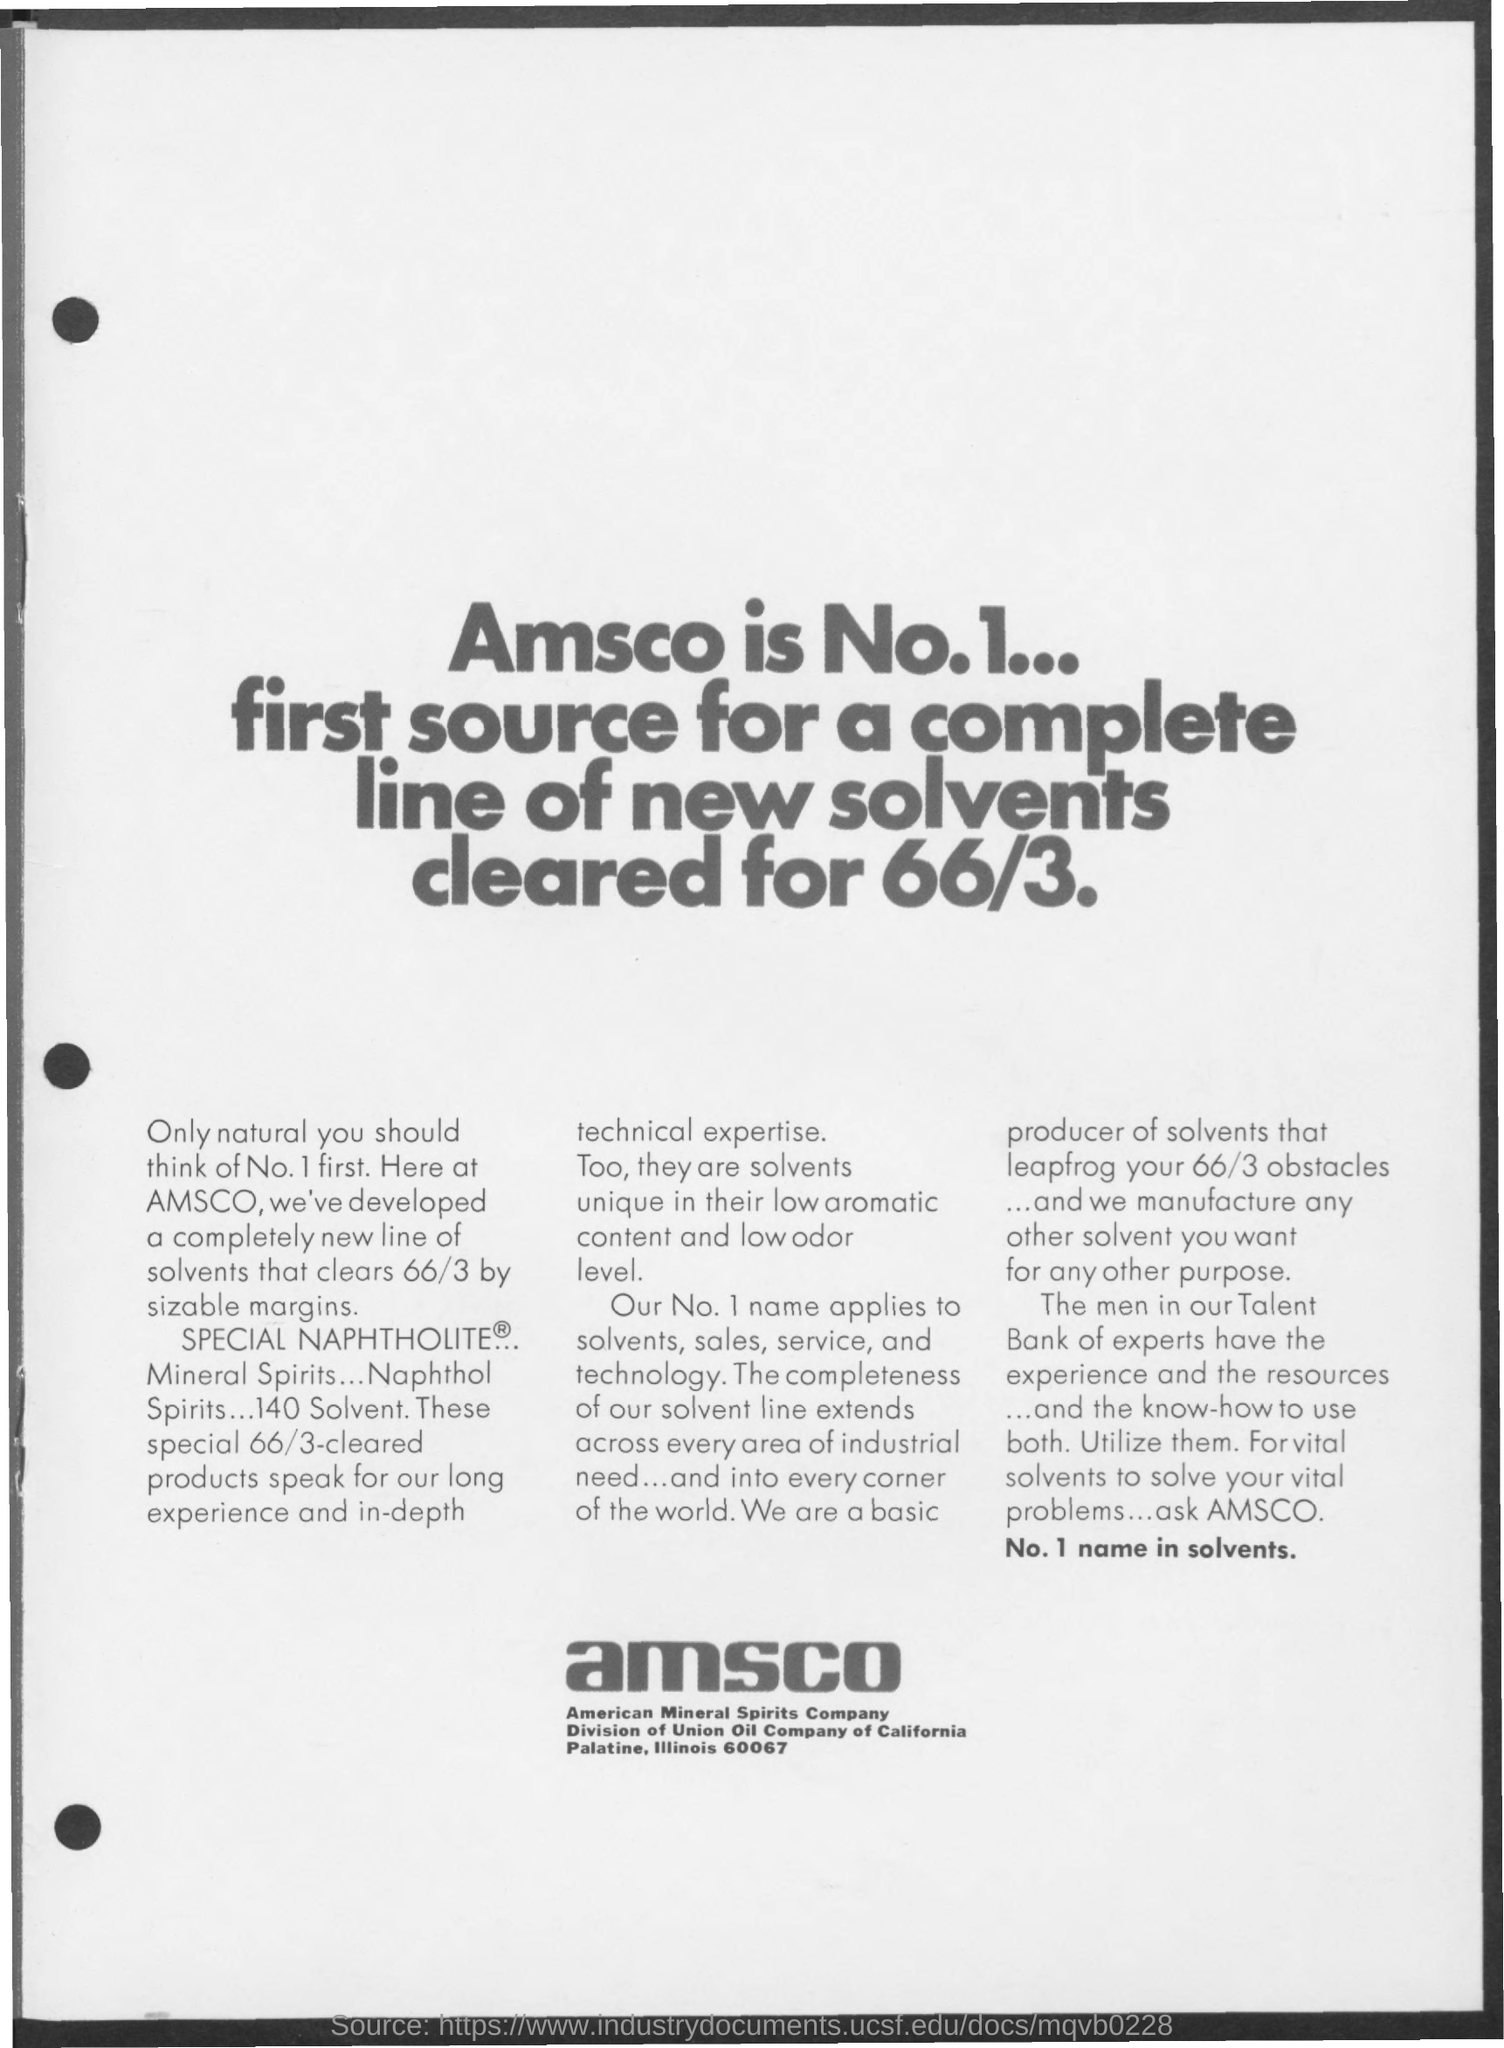What is the fullform of Amsco?
Your answer should be compact. American Mineral Spirits Company. 